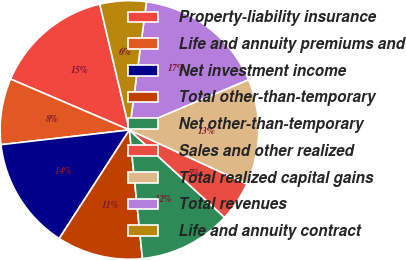<chart> <loc_0><loc_0><loc_500><loc_500><pie_chart><fcel>Property-liability insurance<fcel>Life and annuity premiums and<fcel>Net investment income<fcel>Total other-than-temporary<fcel>Net other-than-temporary<fcel>Sales and other realized<fcel>Total realized capital gains<fcel>Total revenues<fcel>Life and annuity contract<nl><fcel>14.88%<fcel>8.26%<fcel>14.05%<fcel>10.74%<fcel>11.57%<fcel>4.96%<fcel>13.22%<fcel>16.53%<fcel>5.79%<nl></chart> 